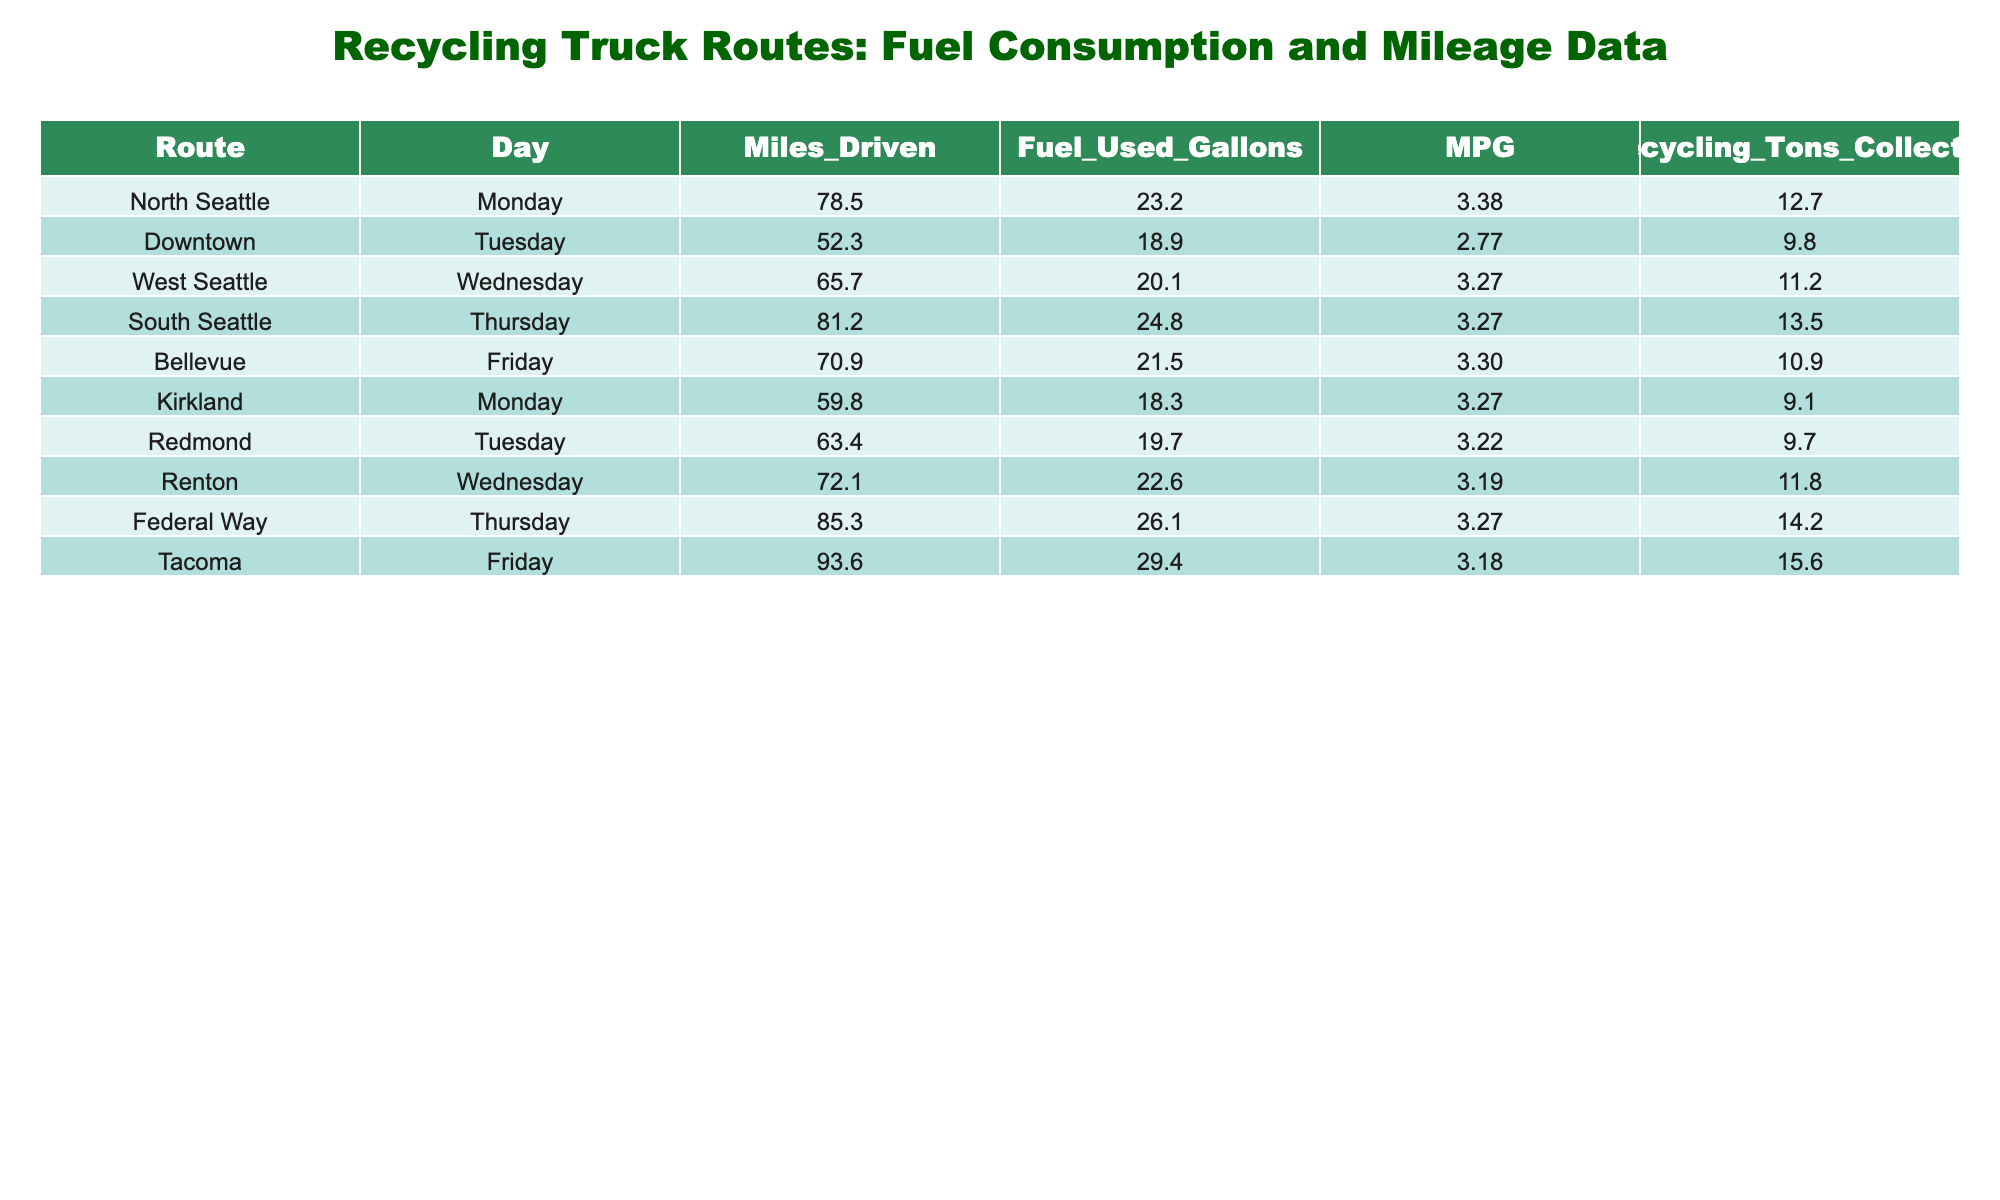What is the total fuel used on Thursday routes? The fuel used on Thursday routes is 24.8 gallons from South Seattle and 26.1 gallons from Federal Way. Summing these, we get 24.8 + 26.1 = 50.9 gallons.
Answer: 50.9 gallons Which route had the highest MPG and what was it? Upon checking the MPG column, South Seattle, Tacoma, and West Seattle routes each had 3.27 MPG, but we note that Tacoma had the lowest fuel consumption among the highest MPG routes at 29.4 gallons, making it the most efficient. Therefore, while they share the same MPG, Tacoma stands out for this reason.
Answer: 3.27 How many total miles were driven on Friday routes? On Friday, the miles driven for Bellevue and Tacoma routes were 70.9 and 93.6 respectively. Adding these gives us 70.9 + 93.6 = 164.5 miles.
Answer: 164.5 miles Did Redmond use more fuel than Kirkland? Redmond used 19.7 gallons and Kirkland used 18.3 gallons. Since 19.7 is greater than 18.3, Redmond used more fuel than Kirkland.
Answer: Yes What is the combined tonnage of recyclables collected on Monday routes? On Monday, North Seattle collected 12.7 tons and Kirkland collected 9.1 tons. Adding these gives us 12.7 + 9.1 = 21.8 tons.
Answer: 21.8 tons What is the average fuel consumption of the routes on Tuesday? On Tuesday, Downtown used 18.9 gallons and Redmond used 19.7 gallons. Summing these yields 18.9 + 19.7 = 38.6 gallons. To find the average, we divide by 2 (the number of Tuesday routes), which is 38.6 / 2 = 19.3 gallons.
Answer: 19.3 gallons Which route collected the least amount of recyclables, and how much was it? The least amount of recyclables collected is from Kirkland at 9.1 tons, as seen in the recycling tons column.
Answer: 9.1 tons What is the difference in fuel used between Federal Way and Tacoma? Federal Way used 26.1 gallons and Tacoma used 29.4 gallons. To find the difference, we subtract the lesser from the greater: 29.4 - 26.1 = 3.3 gallons.
Answer: 3.3 gallons How much more fuel did South Seattle use compared to West Seattle? South Seattle used 24.8 gallons and West Seattle used 20.1 gallons. The difference is calculated as 24.8 - 20.1 = 4.7 gallons.
Answer: 4.7 gallons What is the average MPG across all routes? To calculate the average MPG, we sum all the MPGs: (3.38 + 2.77 + 3.27 + 3.27 + 3.30 + 3.27 + 3.22 + 3.19 + 3.27 + 3.18) = 32.1. Then, divide this sum by the number of routes (10): 32.1 / 10 = 3.21.
Answer: 3.21 